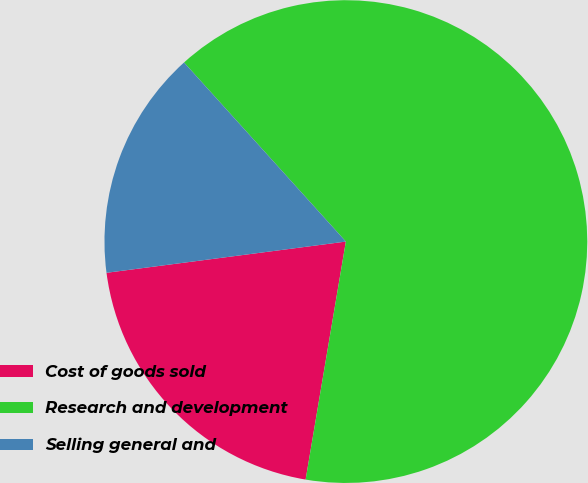Convert chart. <chart><loc_0><loc_0><loc_500><loc_500><pie_chart><fcel>Cost of goods sold<fcel>Research and development<fcel>Selling general and<nl><fcel>20.27%<fcel>64.36%<fcel>15.37%<nl></chart> 